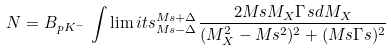<formula> <loc_0><loc_0><loc_500><loc_500>N = B _ { p K ^ { - } } \, \int \lim i t s _ { M _ { \L } s - \Delta } ^ { M _ { \L } s + \Delta } \frac { 2 M _ { \L } s M _ { X } \Gamma _ { \L } s d M _ { X } } { ( M _ { X } ^ { 2 } - M _ { \L } s ^ { 2 } ) ^ { 2 } + ( M _ { \L } s \Gamma _ { \L } s ) ^ { 2 } }</formula> 